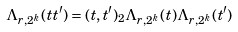Convert formula to latex. <formula><loc_0><loc_0><loc_500><loc_500>\Lambda _ { r , 2 ^ { k } } ( t t ^ { \prime } ) = ( t , t ^ { \prime } ) _ { 2 } \Lambda _ { r , 2 ^ { k } } ( t ) \Lambda _ { r , 2 ^ { k } } ( t ^ { \prime } )</formula> 